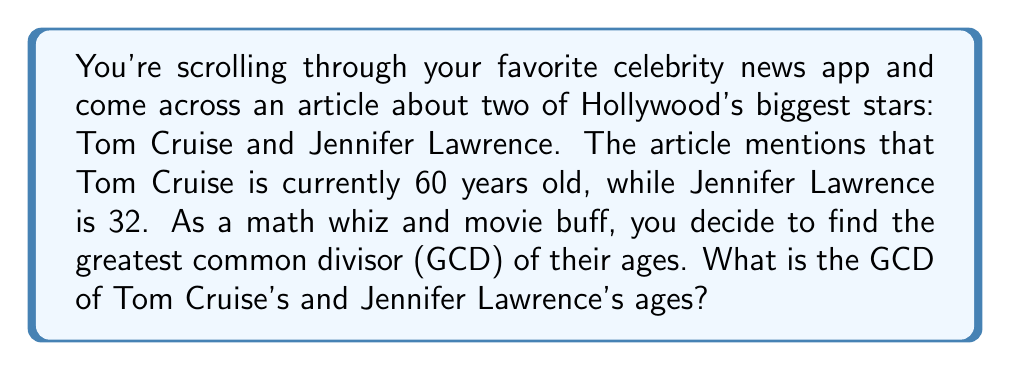Teach me how to tackle this problem. To find the greatest common divisor (GCD) of Tom Cruise's age (60) and Jennifer Lawrence's age (32), we can use the Euclidean algorithm. This algorithm states that the GCD of two numbers $a$ and $b$ is the same as the GCD of $b$ and the remainder of $a$ divided by $b$.

Let's apply the algorithm:

1) First, set up the equation:
   $60 = 1 \times 32 + 28$

2) Now, we repeat the process with 32 and 28:
   $32 = 1 \times 28 + 4$

3) Continue with 28 and 4:
   $28 = 7 \times 4 + 0$

4) The process stops when we get a remainder of 0.

The last non-zero remainder is 4, so this is the GCD of 60 and 32.

We can verify this:
$60 = 2^2 \times 3 \times 5$
$32 = 2^5$

The common factors are $2^2 = 4$, which confirms our result.
Answer: The greatest common divisor of Tom Cruise's age (60) and Jennifer Lawrence's age (32) is 4. 